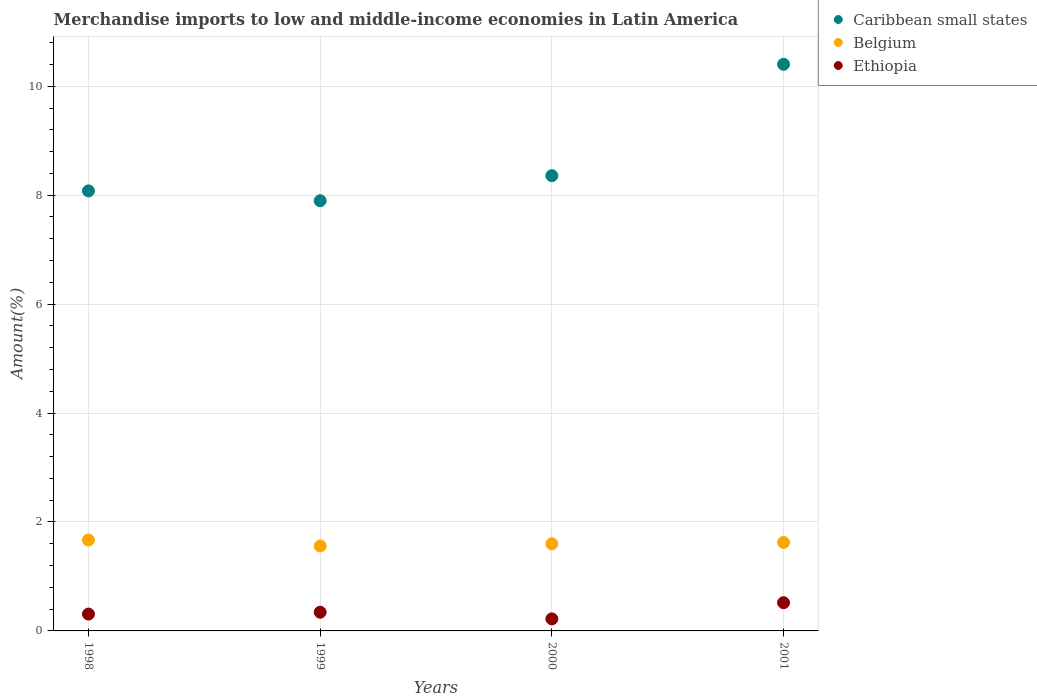How many different coloured dotlines are there?
Give a very brief answer. 3. Is the number of dotlines equal to the number of legend labels?
Your answer should be very brief. Yes. What is the percentage of amount earned from merchandise imports in Ethiopia in 2000?
Your response must be concise. 0.22. Across all years, what is the maximum percentage of amount earned from merchandise imports in Belgium?
Ensure brevity in your answer.  1.67. Across all years, what is the minimum percentage of amount earned from merchandise imports in Caribbean small states?
Offer a terse response. 7.9. In which year was the percentage of amount earned from merchandise imports in Ethiopia maximum?
Your answer should be very brief. 2001. What is the total percentage of amount earned from merchandise imports in Belgium in the graph?
Offer a very short reply. 6.45. What is the difference between the percentage of amount earned from merchandise imports in Ethiopia in 1999 and that in 2000?
Give a very brief answer. 0.12. What is the difference between the percentage of amount earned from merchandise imports in Belgium in 1998 and the percentage of amount earned from merchandise imports in Ethiopia in 1999?
Keep it short and to the point. 1.33. What is the average percentage of amount earned from merchandise imports in Belgium per year?
Ensure brevity in your answer.  1.61. In the year 2000, what is the difference between the percentage of amount earned from merchandise imports in Belgium and percentage of amount earned from merchandise imports in Caribbean small states?
Offer a terse response. -6.76. What is the ratio of the percentage of amount earned from merchandise imports in Ethiopia in 1998 to that in 2000?
Provide a succinct answer. 1.4. Is the difference between the percentage of amount earned from merchandise imports in Belgium in 1999 and 2000 greater than the difference between the percentage of amount earned from merchandise imports in Caribbean small states in 1999 and 2000?
Give a very brief answer. Yes. What is the difference between the highest and the second highest percentage of amount earned from merchandise imports in Ethiopia?
Keep it short and to the point. 0.17. What is the difference between the highest and the lowest percentage of amount earned from merchandise imports in Caribbean small states?
Your response must be concise. 2.51. In how many years, is the percentage of amount earned from merchandise imports in Caribbean small states greater than the average percentage of amount earned from merchandise imports in Caribbean small states taken over all years?
Your answer should be compact. 1. Is the sum of the percentage of amount earned from merchandise imports in Belgium in 2000 and 2001 greater than the maximum percentage of amount earned from merchandise imports in Ethiopia across all years?
Ensure brevity in your answer.  Yes. Is it the case that in every year, the sum of the percentage of amount earned from merchandise imports in Caribbean small states and percentage of amount earned from merchandise imports in Belgium  is greater than the percentage of amount earned from merchandise imports in Ethiopia?
Your answer should be very brief. Yes. Are the values on the major ticks of Y-axis written in scientific E-notation?
Your answer should be very brief. No. Does the graph contain any zero values?
Your answer should be compact. No. Does the graph contain grids?
Provide a short and direct response. Yes. How many legend labels are there?
Your answer should be very brief. 3. How are the legend labels stacked?
Provide a short and direct response. Vertical. What is the title of the graph?
Your answer should be compact. Merchandise imports to low and middle-income economies in Latin America. What is the label or title of the Y-axis?
Ensure brevity in your answer.  Amount(%). What is the Amount(%) of Caribbean small states in 1998?
Your answer should be very brief. 8.08. What is the Amount(%) of Belgium in 1998?
Your answer should be very brief. 1.67. What is the Amount(%) in Ethiopia in 1998?
Give a very brief answer. 0.31. What is the Amount(%) in Caribbean small states in 1999?
Your answer should be compact. 7.9. What is the Amount(%) in Belgium in 1999?
Offer a terse response. 1.56. What is the Amount(%) in Ethiopia in 1999?
Offer a terse response. 0.34. What is the Amount(%) in Caribbean small states in 2000?
Provide a succinct answer. 8.36. What is the Amount(%) of Belgium in 2000?
Provide a succinct answer. 1.6. What is the Amount(%) in Ethiopia in 2000?
Give a very brief answer. 0.22. What is the Amount(%) in Caribbean small states in 2001?
Your answer should be very brief. 10.4. What is the Amount(%) of Belgium in 2001?
Your answer should be compact. 1.63. What is the Amount(%) of Ethiopia in 2001?
Make the answer very short. 0.52. Across all years, what is the maximum Amount(%) in Caribbean small states?
Offer a terse response. 10.4. Across all years, what is the maximum Amount(%) in Belgium?
Offer a very short reply. 1.67. Across all years, what is the maximum Amount(%) of Ethiopia?
Your answer should be compact. 0.52. Across all years, what is the minimum Amount(%) of Caribbean small states?
Your answer should be compact. 7.9. Across all years, what is the minimum Amount(%) in Belgium?
Make the answer very short. 1.56. Across all years, what is the minimum Amount(%) of Ethiopia?
Your response must be concise. 0.22. What is the total Amount(%) of Caribbean small states in the graph?
Your response must be concise. 34.74. What is the total Amount(%) in Belgium in the graph?
Ensure brevity in your answer.  6.45. What is the total Amount(%) of Ethiopia in the graph?
Your answer should be very brief. 1.39. What is the difference between the Amount(%) of Caribbean small states in 1998 and that in 1999?
Your answer should be very brief. 0.18. What is the difference between the Amount(%) in Belgium in 1998 and that in 1999?
Provide a succinct answer. 0.11. What is the difference between the Amount(%) in Ethiopia in 1998 and that in 1999?
Your response must be concise. -0.03. What is the difference between the Amount(%) in Caribbean small states in 1998 and that in 2000?
Your response must be concise. -0.28. What is the difference between the Amount(%) of Belgium in 1998 and that in 2000?
Your answer should be compact. 0.07. What is the difference between the Amount(%) of Ethiopia in 1998 and that in 2000?
Ensure brevity in your answer.  0.09. What is the difference between the Amount(%) of Caribbean small states in 1998 and that in 2001?
Your answer should be very brief. -2.32. What is the difference between the Amount(%) of Belgium in 1998 and that in 2001?
Offer a very short reply. 0.04. What is the difference between the Amount(%) in Ethiopia in 1998 and that in 2001?
Keep it short and to the point. -0.21. What is the difference between the Amount(%) in Caribbean small states in 1999 and that in 2000?
Keep it short and to the point. -0.46. What is the difference between the Amount(%) in Belgium in 1999 and that in 2000?
Provide a short and direct response. -0.04. What is the difference between the Amount(%) in Ethiopia in 1999 and that in 2000?
Offer a terse response. 0.12. What is the difference between the Amount(%) of Caribbean small states in 1999 and that in 2001?
Give a very brief answer. -2.5. What is the difference between the Amount(%) in Belgium in 1999 and that in 2001?
Keep it short and to the point. -0.07. What is the difference between the Amount(%) of Ethiopia in 1999 and that in 2001?
Offer a very short reply. -0.17. What is the difference between the Amount(%) of Caribbean small states in 2000 and that in 2001?
Offer a very short reply. -2.04. What is the difference between the Amount(%) of Belgium in 2000 and that in 2001?
Offer a very short reply. -0.03. What is the difference between the Amount(%) in Ethiopia in 2000 and that in 2001?
Provide a succinct answer. -0.3. What is the difference between the Amount(%) of Caribbean small states in 1998 and the Amount(%) of Belgium in 1999?
Keep it short and to the point. 6.52. What is the difference between the Amount(%) of Caribbean small states in 1998 and the Amount(%) of Ethiopia in 1999?
Ensure brevity in your answer.  7.74. What is the difference between the Amount(%) of Belgium in 1998 and the Amount(%) of Ethiopia in 1999?
Your answer should be compact. 1.33. What is the difference between the Amount(%) in Caribbean small states in 1998 and the Amount(%) in Belgium in 2000?
Make the answer very short. 6.48. What is the difference between the Amount(%) in Caribbean small states in 1998 and the Amount(%) in Ethiopia in 2000?
Give a very brief answer. 7.86. What is the difference between the Amount(%) in Belgium in 1998 and the Amount(%) in Ethiopia in 2000?
Provide a short and direct response. 1.45. What is the difference between the Amount(%) of Caribbean small states in 1998 and the Amount(%) of Belgium in 2001?
Give a very brief answer. 6.45. What is the difference between the Amount(%) of Caribbean small states in 1998 and the Amount(%) of Ethiopia in 2001?
Provide a succinct answer. 7.56. What is the difference between the Amount(%) of Belgium in 1998 and the Amount(%) of Ethiopia in 2001?
Keep it short and to the point. 1.15. What is the difference between the Amount(%) of Caribbean small states in 1999 and the Amount(%) of Belgium in 2000?
Give a very brief answer. 6.3. What is the difference between the Amount(%) in Caribbean small states in 1999 and the Amount(%) in Ethiopia in 2000?
Your answer should be very brief. 7.68. What is the difference between the Amount(%) of Belgium in 1999 and the Amount(%) of Ethiopia in 2000?
Ensure brevity in your answer.  1.34. What is the difference between the Amount(%) of Caribbean small states in 1999 and the Amount(%) of Belgium in 2001?
Your answer should be compact. 6.27. What is the difference between the Amount(%) in Caribbean small states in 1999 and the Amount(%) in Ethiopia in 2001?
Keep it short and to the point. 7.38. What is the difference between the Amount(%) in Belgium in 1999 and the Amount(%) in Ethiopia in 2001?
Ensure brevity in your answer.  1.04. What is the difference between the Amount(%) of Caribbean small states in 2000 and the Amount(%) of Belgium in 2001?
Offer a very short reply. 6.73. What is the difference between the Amount(%) in Caribbean small states in 2000 and the Amount(%) in Ethiopia in 2001?
Offer a terse response. 7.84. What is the difference between the Amount(%) in Belgium in 2000 and the Amount(%) in Ethiopia in 2001?
Offer a terse response. 1.08. What is the average Amount(%) of Caribbean small states per year?
Your answer should be very brief. 8.69. What is the average Amount(%) of Belgium per year?
Ensure brevity in your answer.  1.61. What is the average Amount(%) of Ethiopia per year?
Give a very brief answer. 0.35. In the year 1998, what is the difference between the Amount(%) of Caribbean small states and Amount(%) of Belgium?
Offer a terse response. 6.41. In the year 1998, what is the difference between the Amount(%) of Caribbean small states and Amount(%) of Ethiopia?
Make the answer very short. 7.77. In the year 1998, what is the difference between the Amount(%) in Belgium and Amount(%) in Ethiopia?
Keep it short and to the point. 1.36. In the year 1999, what is the difference between the Amount(%) in Caribbean small states and Amount(%) in Belgium?
Provide a succinct answer. 6.34. In the year 1999, what is the difference between the Amount(%) of Caribbean small states and Amount(%) of Ethiopia?
Give a very brief answer. 7.55. In the year 1999, what is the difference between the Amount(%) in Belgium and Amount(%) in Ethiopia?
Offer a very short reply. 1.22. In the year 2000, what is the difference between the Amount(%) of Caribbean small states and Amount(%) of Belgium?
Your answer should be compact. 6.76. In the year 2000, what is the difference between the Amount(%) in Caribbean small states and Amount(%) in Ethiopia?
Offer a very short reply. 8.14. In the year 2000, what is the difference between the Amount(%) in Belgium and Amount(%) in Ethiopia?
Your response must be concise. 1.38. In the year 2001, what is the difference between the Amount(%) in Caribbean small states and Amount(%) in Belgium?
Make the answer very short. 8.78. In the year 2001, what is the difference between the Amount(%) of Caribbean small states and Amount(%) of Ethiopia?
Make the answer very short. 9.89. In the year 2001, what is the difference between the Amount(%) of Belgium and Amount(%) of Ethiopia?
Your response must be concise. 1.11. What is the ratio of the Amount(%) in Caribbean small states in 1998 to that in 1999?
Your response must be concise. 1.02. What is the ratio of the Amount(%) of Belgium in 1998 to that in 1999?
Offer a very short reply. 1.07. What is the ratio of the Amount(%) of Ethiopia in 1998 to that in 1999?
Keep it short and to the point. 0.9. What is the ratio of the Amount(%) of Caribbean small states in 1998 to that in 2000?
Provide a short and direct response. 0.97. What is the ratio of the Amount(%) of Belgium in 1998 to that in 2000?
Give a very brief answer. 1.04. What is the ratio of the Amount(%) of Ethiopia in 1998 to that in 2000?
Your answer should be very brief. 1.4. What is the ratio of the Amount(%) of Caribbean small states in 1998 to that in 2001?
Make the answer very short. 0.78. What is the ratio of the Amount(%) of Belgium in 1998 to that in 2001?
Your response must be concise. 1.03. What is the ratio of the Amount(%) of Ethiopia in 1998 to that in 2001?
Keep it short and to the point. 0.6. What is the ratio of the Amount(%) in Caribbean small states in 1999 to that in 2000?
Your response must be concise. 0.94. What is the ratio of the Amount(%) of Belgium in 1999 to that in 2000?
Ensure brevity in your answer.  0.97. What is the ratio of the Amount(%) in Ethiopia in 1999 to that in 2000?
Make the answer very short. 1.55. What is the ratio of the Amount(%) in Caribbean small states in 1999 to that in 2001?
Give a very brief answer. 0.76. What is the ratio of the Amount(%) of Belgium in 1999 to that in 2001?
Your answer should be compact. 0.96. What is the ratio of the Amount(%) in Ethiopia in 1999 to that in 2001?
Offer a terse response. 0.66. What is the ratio of the Amount(%) in Caribbean small states in 2000 to that in 2001?
Your response must be concise. 0.8. What is the ratio of the Amount(%) in Belgium in 2000 to that in 2001?
Offer a very short reply. 0.98. What is the ratio of the Amount(%) of Ethiopia in 2000 to that in 2001?
Ensure brevity in your answer.  0.43. What is the difference between the highest and the second highest Amount(%) of Caribbean small states?
Give a very brief answer. 2.04. What is the difference between the highest and the second highest Amount(%) of Belgium?
Provide a succinct answer. 0.04. What is the difference between the highest and the second highest Amount(%) of Ethiopia?
Provide a succinct answer. 0.17. What is the difference between the highest and the lowest Amount(%) in Caribbean small states?
Ensure brevity in your answer.  2.5. What is the difference between the highest and the lowest Amount(%) of Belgium?
Provide a succinct answer. 0.11. What is the difference between the highest and the lowest Amount(%) in Ethiopia?
Your answer should be compact. 0.3. 